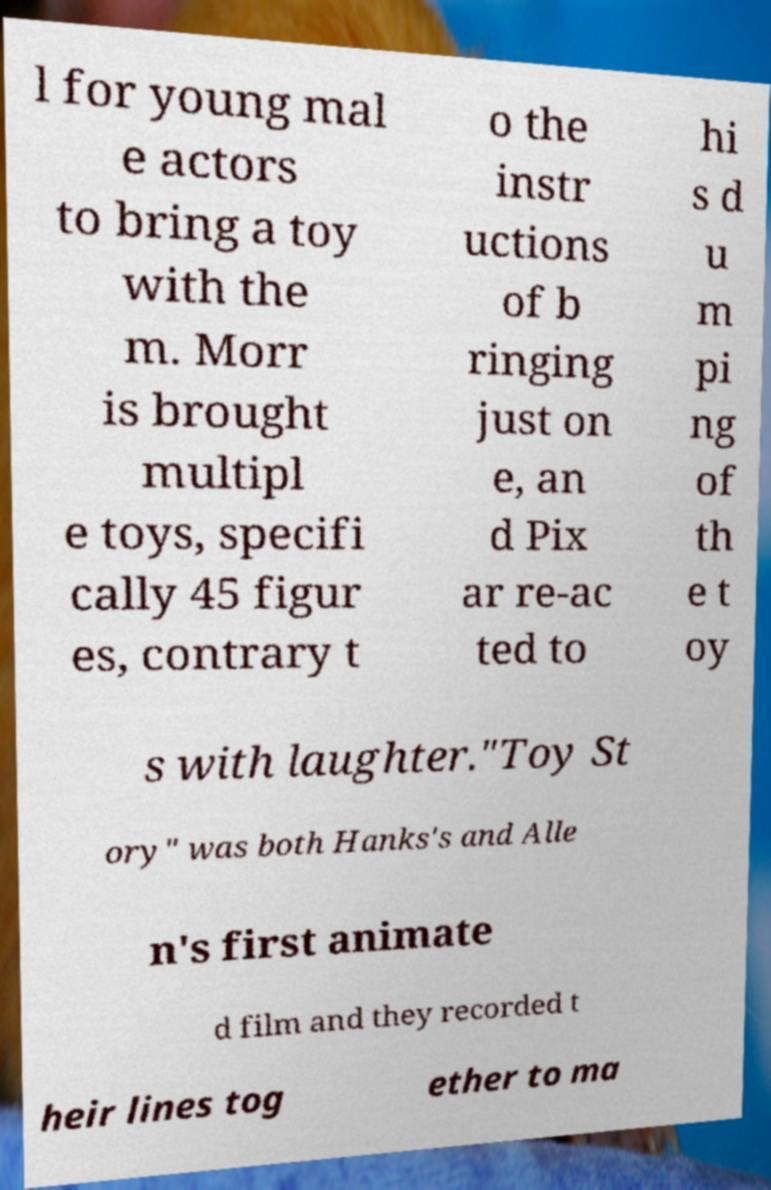Can you read and provide the text displayed in the image?This photo seems to have some interesting text. Can you extract and type it out for me? l for young mal e actors to bring a toy with the m. Morr is brought multipl e toys, specifi cally 45 figur es, contrary t o the instr uctions of b ringing just on e, an d Pix ar re-ac ted to hi s d u m pi ng of th e t oy s with laughter."Toy St ory" was both Hanks's and Alle n's first animate d film and they recorded t heir lines tog ether to ma 